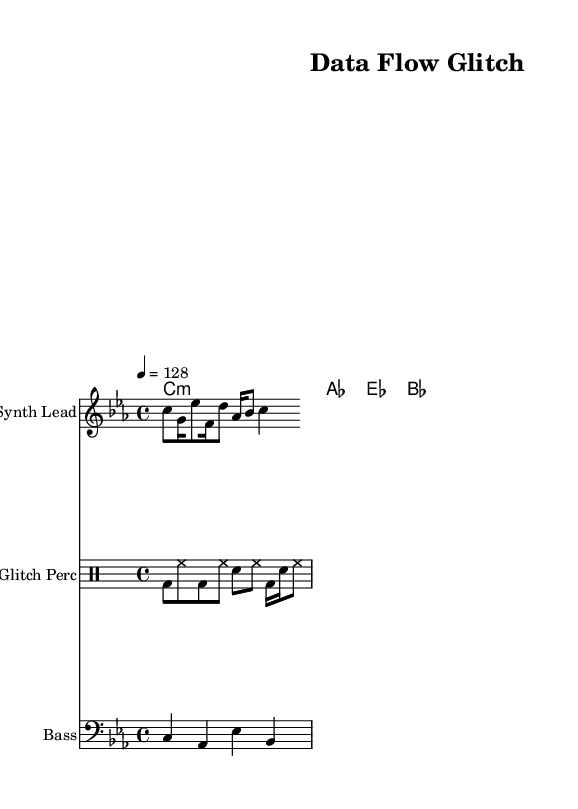What is the key signature of this music? The key signature is C minor, indicated by the two flats in the signature: B flat and E flat.
Answer: C minor What is the time signature of this music? The time signature is 4/4, which shows that there are four beats in each measure and the quarter note gets one beat.
Answer: 4/4 What is the tempo marking for this piece? The tempo marking indicates that the piece should be played at a speed of 128 beats per minute, as specified with "4 = 128".
Answer: 128 How many measures are in the synth lead part? By counting the individual note groupings in the synth lead, we can identify that there are a total of 8 measures based on the provided music data.
Answer: 8 What type of instrumentation is used for the percussion part? The percussion part uses a glitch style, which is characterized by the use of bass drum, hi-hat, and snare sounds, denoted by their abbreviations.
Answer: Glitch What is the main chord used in the harmony? The main chord defined in the harmony section is the C minor chord, indicated clearly under the chord names section.
Answer: C:min What rhythmic elements are emphasized in this glitch-hop track? The rhythmic elements include the use of syncopation and varied note lengths, presenting a dynamic and fragmented rhythm typical of glitch-hop, focusing particularly on the bass drum and snare interactions.
Answer: Syncopation 